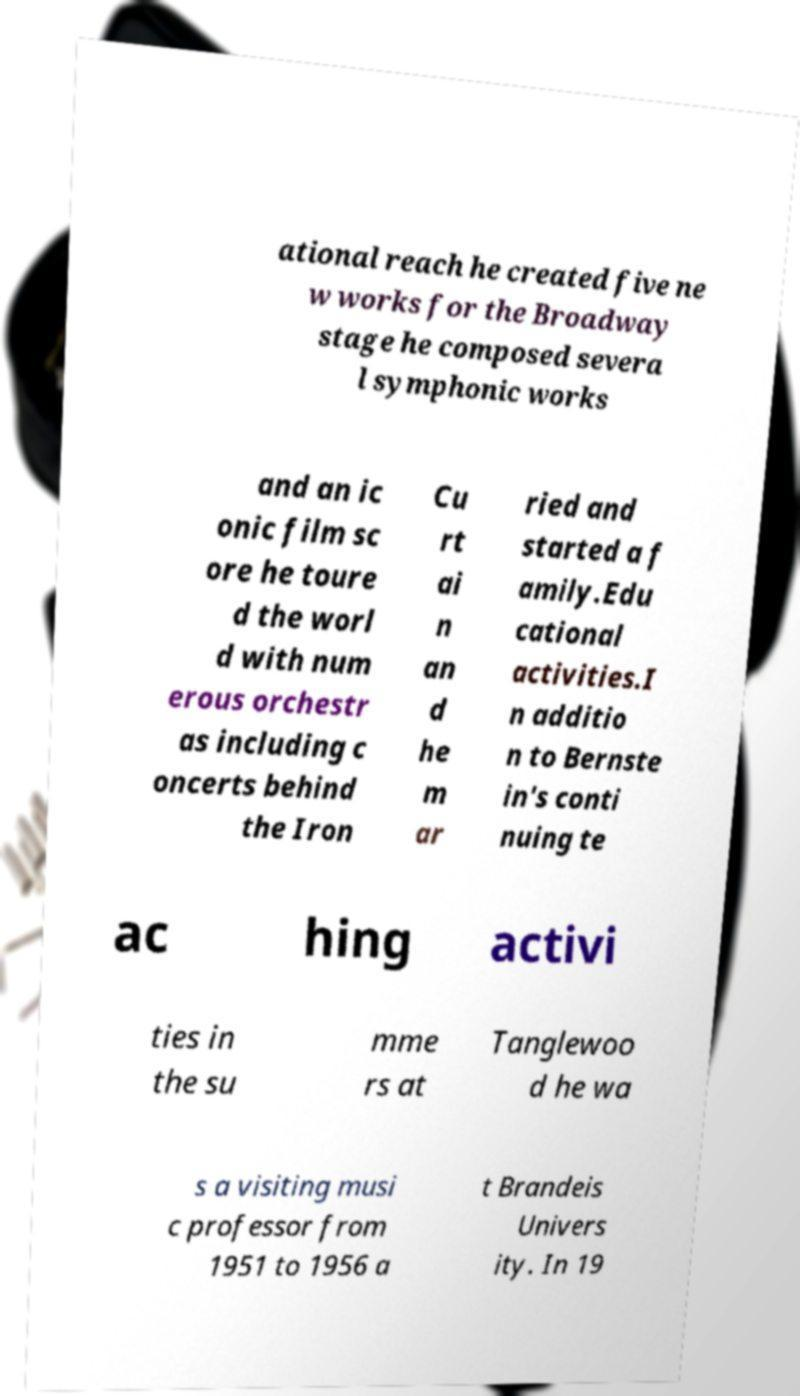Could you assist in decoding the text presented in this image and type it out clearly? ational reach he created five ne w works for the Broadway stage he composed severa l symphonic works and an ic onic film sc ore he toure d the worl d with num erous orchestr as including c oncerts behind the Iron Cu rt ai n an d he m ar ried and started a f amily.Edu cational activities.I n additio n to Bernste in's conti nuing te ac hing activi ties in the su mme rs at Tanglewoo d he wa s a visiting musi c professor from 1951 to 1956 a t Brandeis Univers ity. In 19 